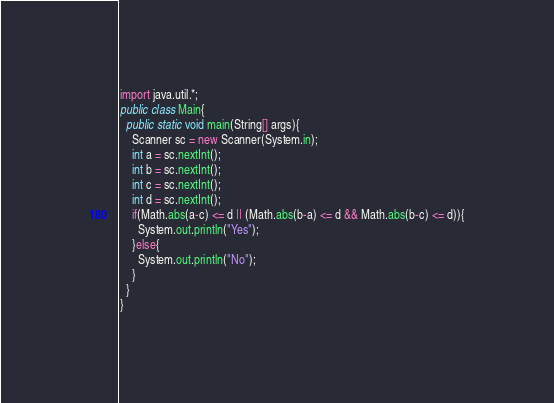<code> <loc_0><loc_0><loc_500><loc_500><_Java_>import java.util.*;
public class Main{
  public static void main(String[] args){
    Scanner sc = new Scanner(System.in);
    int a = sc.nextInt();
    int b = sc.nextInt();
    int c = sc.nextInt();
    int d = sc.nextInt();
    if(Math.abs(a-c) <= d || (Math.abs(b-a) <= d && Math.abs(b-c) <= d)){
      System.out.println("Yes");
    }else{
      System.out.println("No");
    }
  }
}</code> 